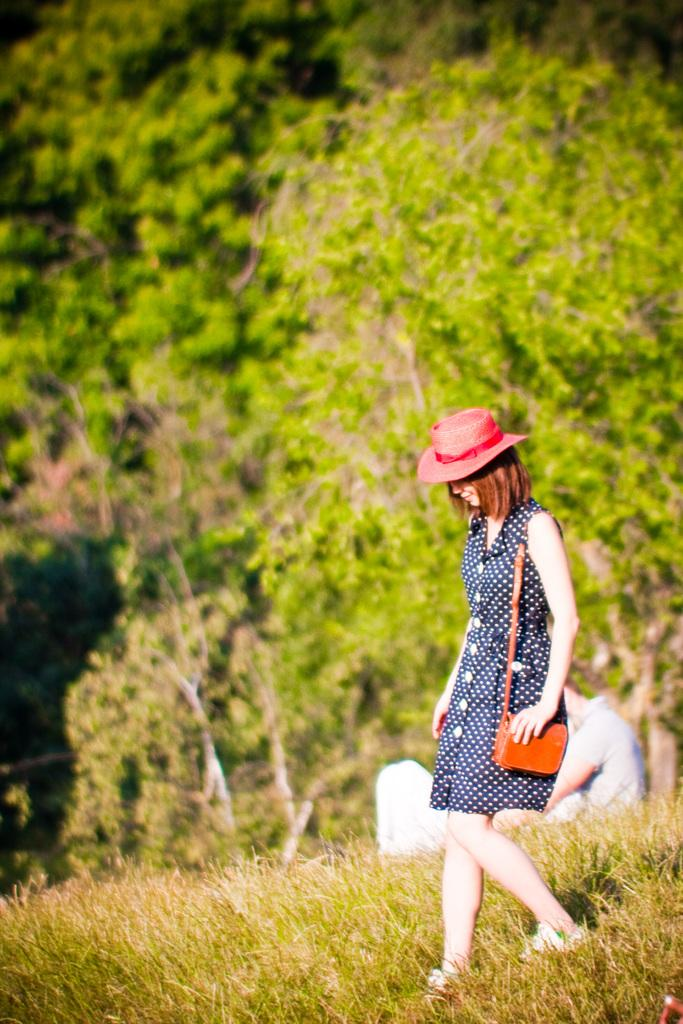Who is the main subject in the image? There is a woman in the image. What is the woman wearing on her head? The woman is wearing a hat. What accessory is the woman carrying in the image? The woman is carrying a handbag. What type of terrain is the woman walking through? The woman is walking through grass. What can be seen in the background of the image? There are trees visible in the background of the image. What type of vest is the woman wearing to protect her from the earth in the image? The woman is not wearing a vest in the image, and there is no indication of any protective gear. 